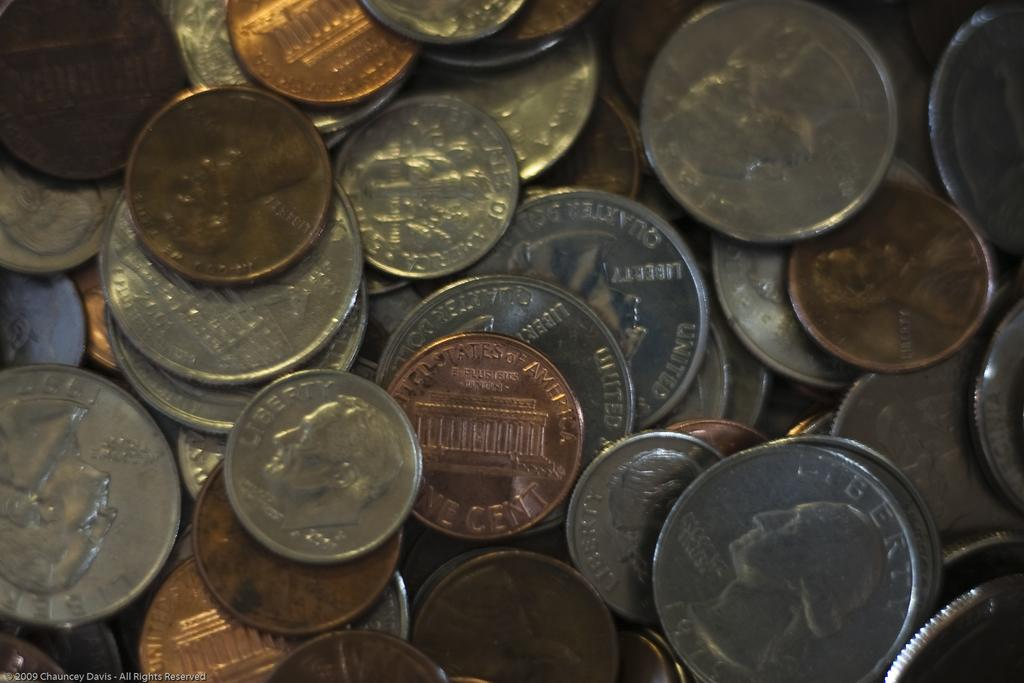<image>
Present a compact description of the photo's key features. A pile of american change including a 2001 dime on the lower left. 